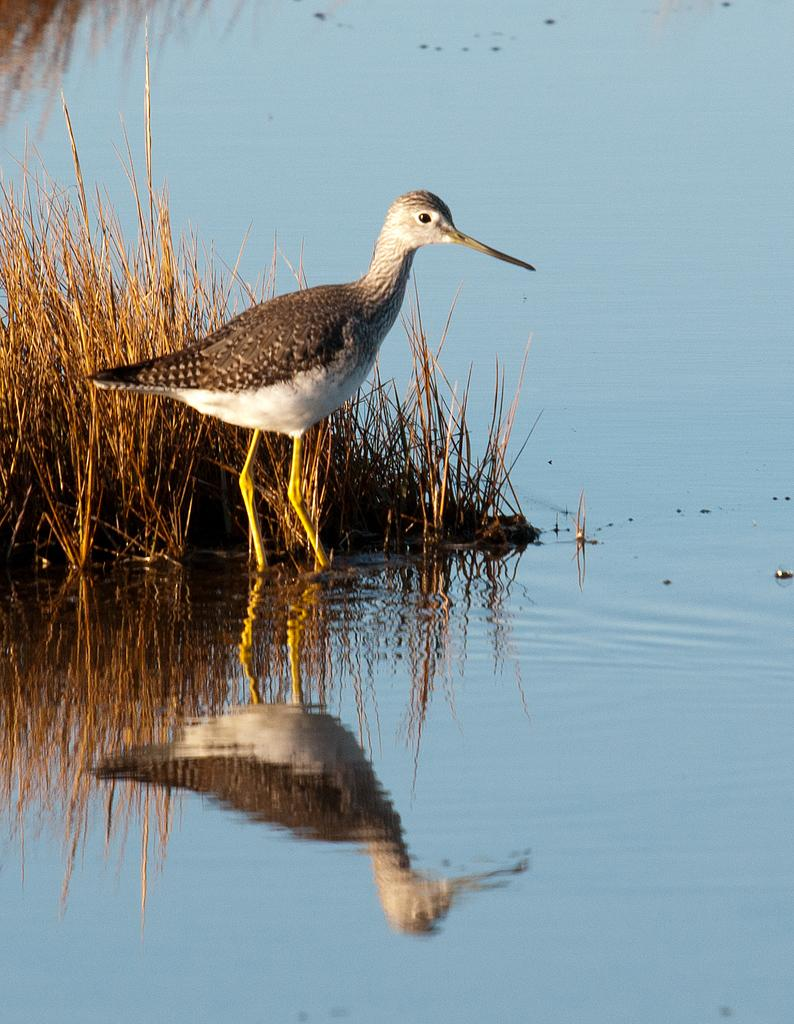What type of bird is in the image? There is a wood sandpiper bird in the image. What is the bird doing in the image? The bird is standing. What type of vegetation is present in the image? The image contains dried grass. What else can be seen in the image besides the bird? There is water visible in the image. Can you describe the bird's reflection in the water? The bird's reflection is visible on the water. What is the topic of the argument taking place in the middle of the image? There is no argument present in the image; it features a wood sandpiper bird standing near water with its reflection visible. How many trees are visible in the image? There are no trees visible in the image. 